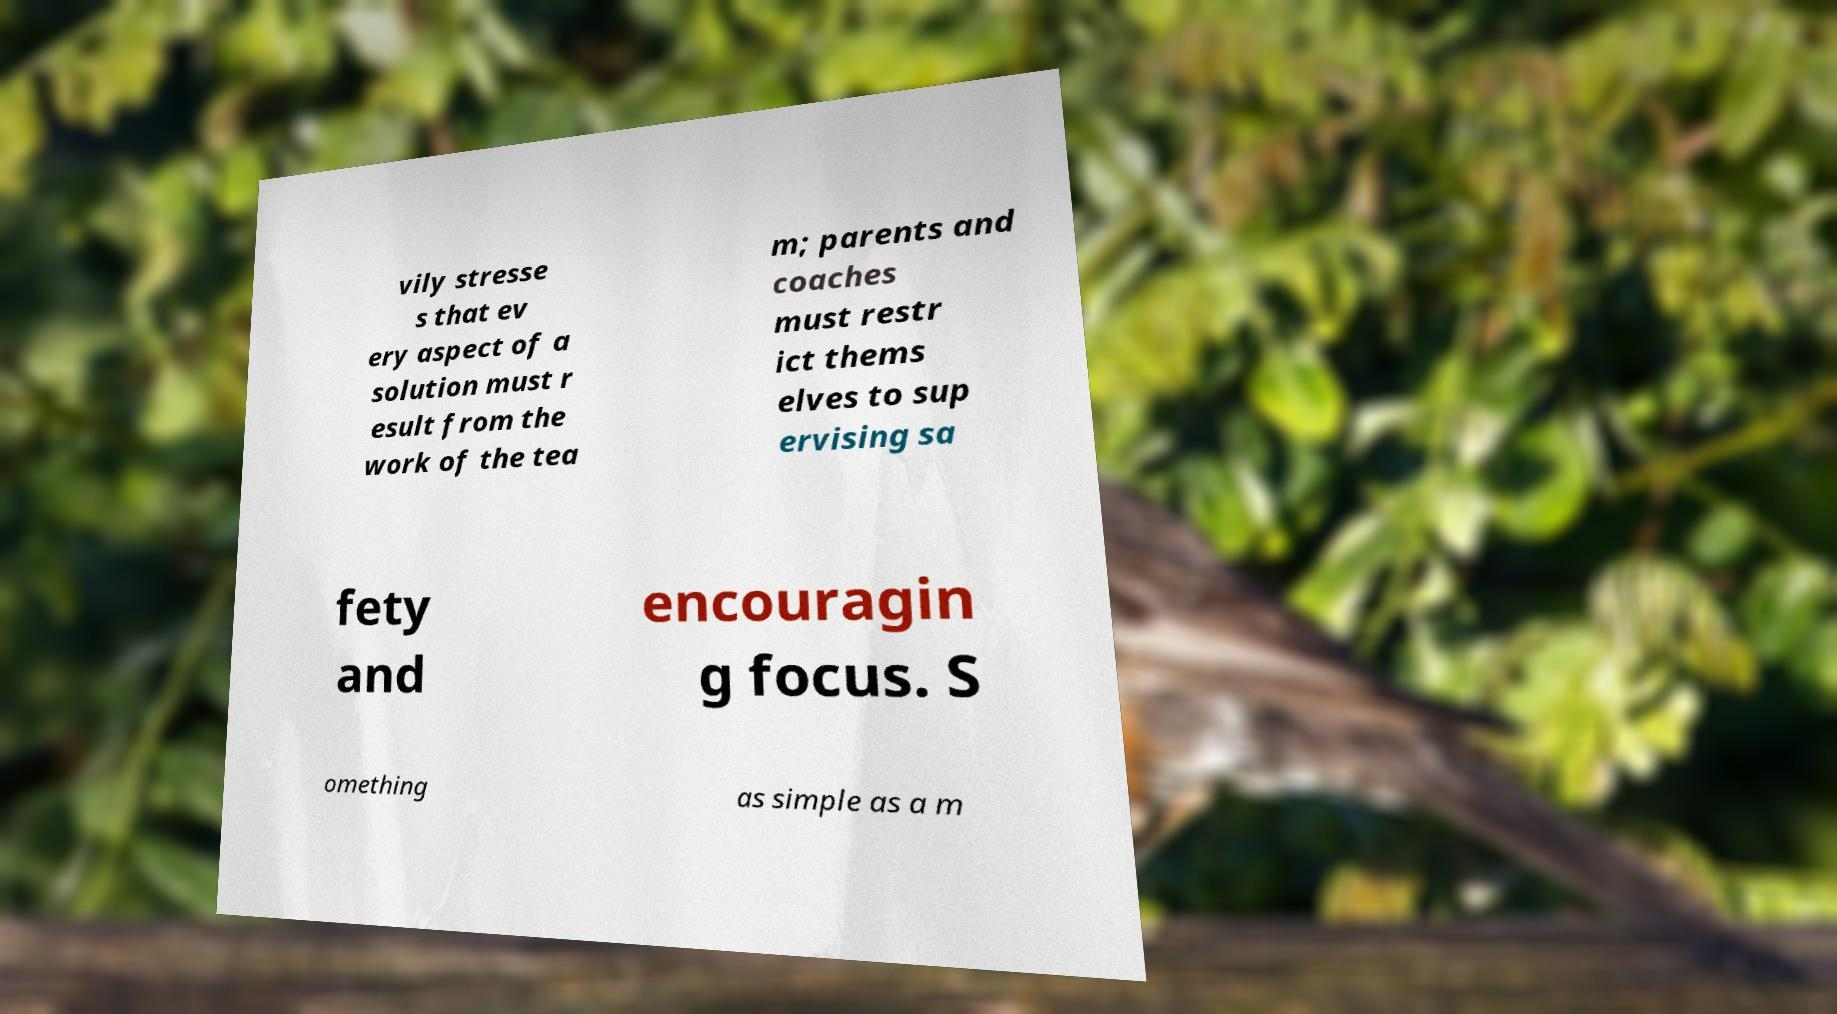Can you read and provide the text displayed in the image?This photo seems to have some interesting text. Can you extract and type it out for me? vily stresse s that ev ery aspect of a solution must r esult from the work of the tea m; parents and coaches must restr ict thems elves to sup ervising sa fety and encouragin g focus. S omething as simple as a m 